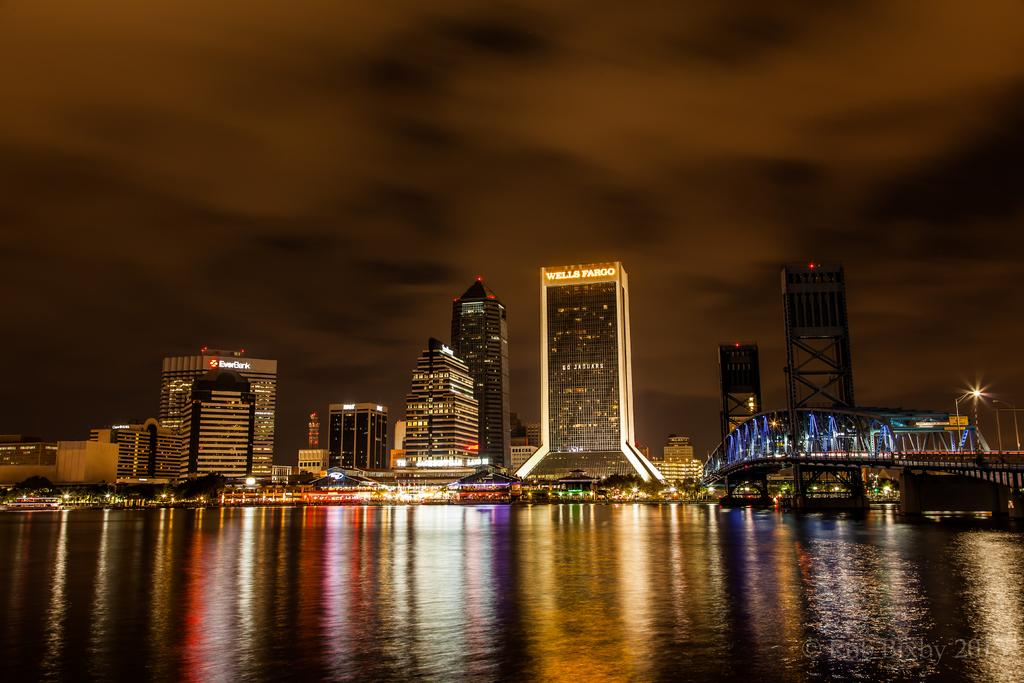<image>
Create a compact narrative representing the image presented. The bank in the background is called ever bank 